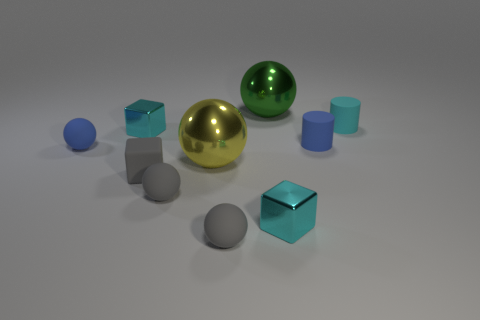Subtract all green shiny balls. How many balls are left? 4 Subtract all purple spheres. How many cyan cubes are left? 2 Subtract all gray spheres. How many spheres are left? 3 Subtract 1 balls. How many balls are left? 4 Subtract all cyan balls. Subtract all cyan cylinders. How many balls are left? 5 Subtract all cylinders. How many objects are left? 8 Add 5 tiny blue rubber cylinders. How many tiny blue rubber cylinders exist? 6 Subtract 0 cyan spheres. How many objects are left? 10 Subtract all green things. Subtract all small metal things. How many objects are left? 7 Add 1 green metal objects. How many green metal objects are left? 2 